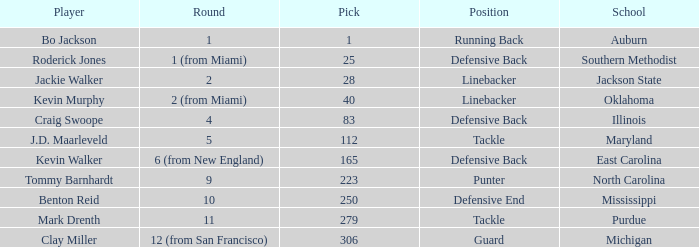What school did bo jackson attend? Auburn. 